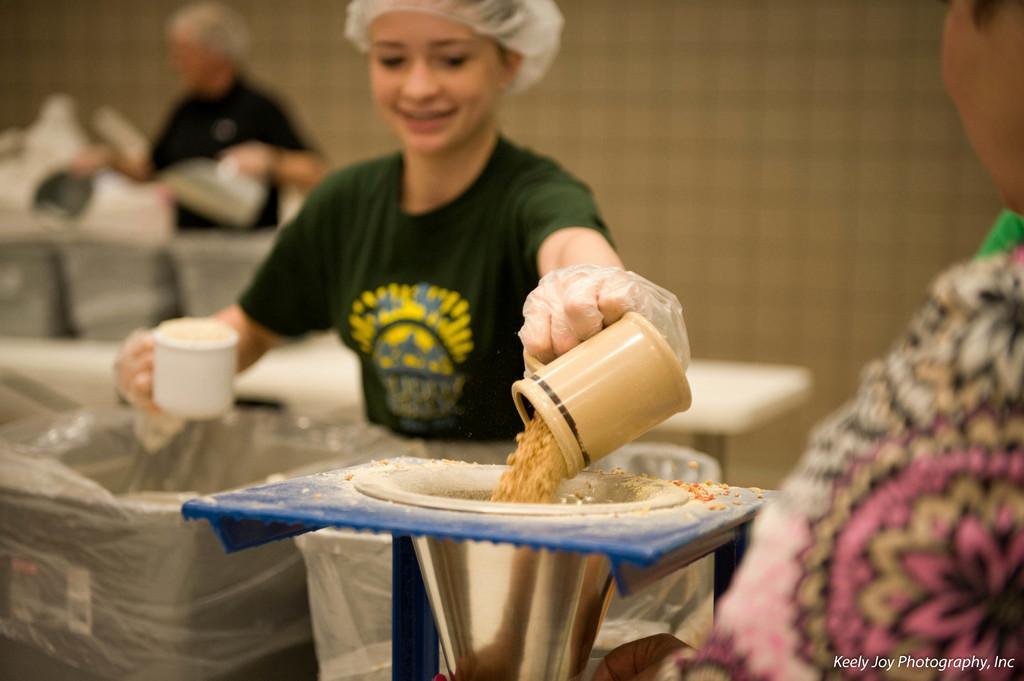Who is present in the image? There is a woman in the image. What is the woman holding in the image? The woman is holding a cup. What activity is the woman engaged in? The woman appears to be grinding grains. What color is the woman's T-shirt in the image? The woman is wearing a green T-shirt. What can be seen in the background of the image? There is a wall in the background of the image. What type of cheese is the woman sneezing in the image? There is no cheese or sneezing present in the image. The woman is grinding grains and holding a cup. 